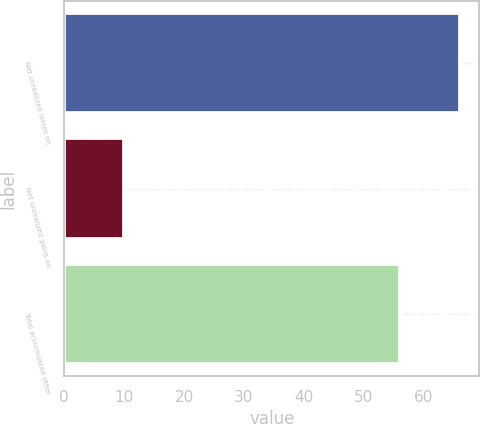Convert chart to OTSL. <chart><loc_0><loc_0><loc_500><loc_500><bar_chart><fcel>Net unrealized losses on<fcel>Net unrealized gains on<fcel>Total accumulated other<nl><fcel>66<fcel>10<fcel>56<nl></chart> 